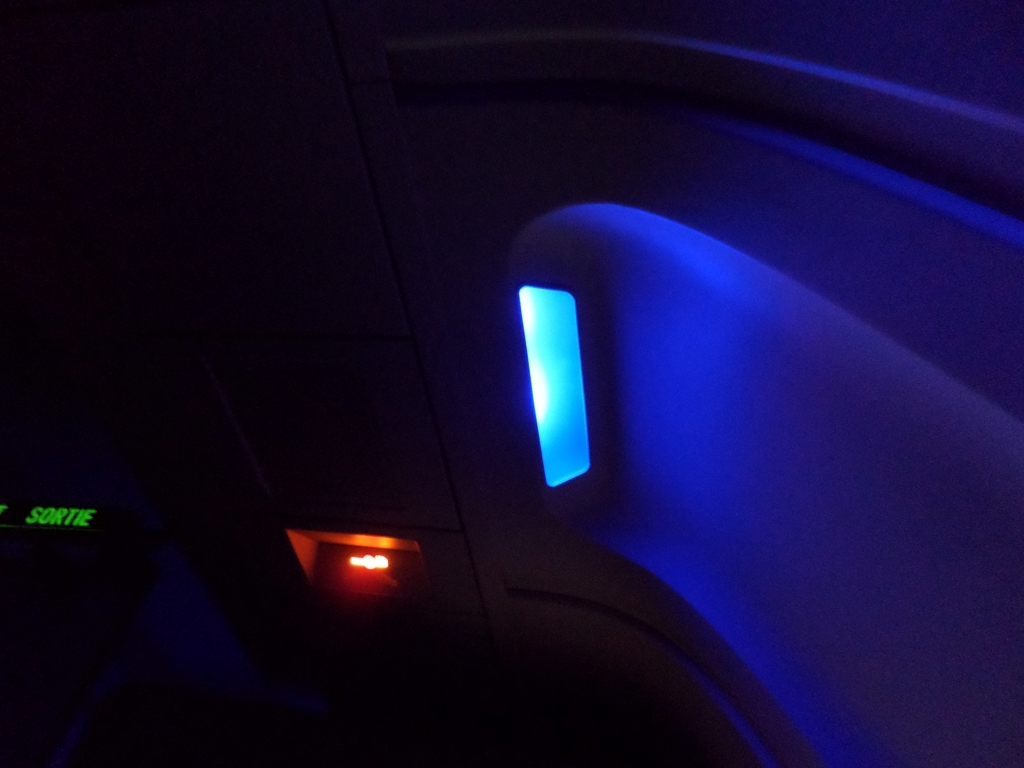Can you describe the mood or atmosphere this image evokes? The image seems to evoke a tranquil and somewhat mysterious atmosphere, likely due to the monochromatic blue light and the surrounding darkness. It might be associated with the calm during an evening flight. 